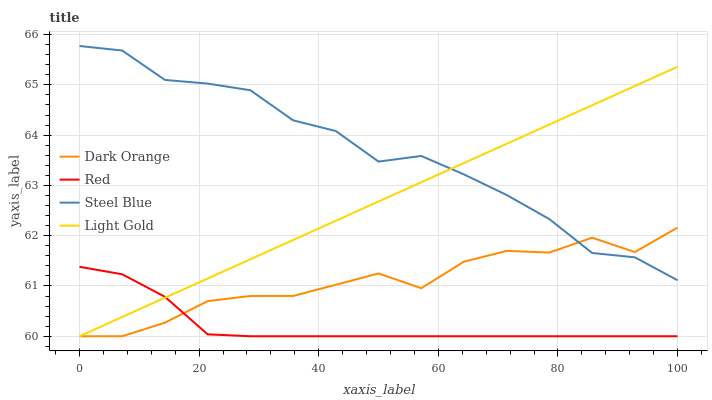Does Red have the minimum area under the curve?
Answer yes or no. Yes. Does Steel Blue have the maximum area under the curve?
Answer yes or no. Yes. Does Light Gold have the minimum area under the curve?
Answer yes or no. No. Does Light Gold have the maximum area under the curve?
Answer yes or no. No. Is Light Gold the smoothest?
Answer yes or no. Yes. Is Steel Blue the roughest?
Answer yes or no. Yes. Is Steel Blue the smoothest?
Answer yes or no. No. Is Light Gold the roughest?
Answer yes or no. No. Does Dark Orange have the lowest value?
Answer yes or no. Yes. Does Steel Blue have the lowest value?
Answer yes or no. No. Does Steel Blue have the highest value?
Answer yes or no. Yes. Does Light Gold have the highest value?
Answer yes or no. No. Is Red less than Steel Blue?
Answer yes or no. Yes. Is Steel Blue greater than Red?
Answer yes or no. Yes. Does Light Gold intersect Steel Blue?
Answer yes or no. Yes. Is Light Gold less than Steel Blue?
Answer yes or no. No. Is Light Gold greater than Steel Blue?
Answer yes or no. No. Does Red intersect Steel Blue?
Answer yes or no. No. 